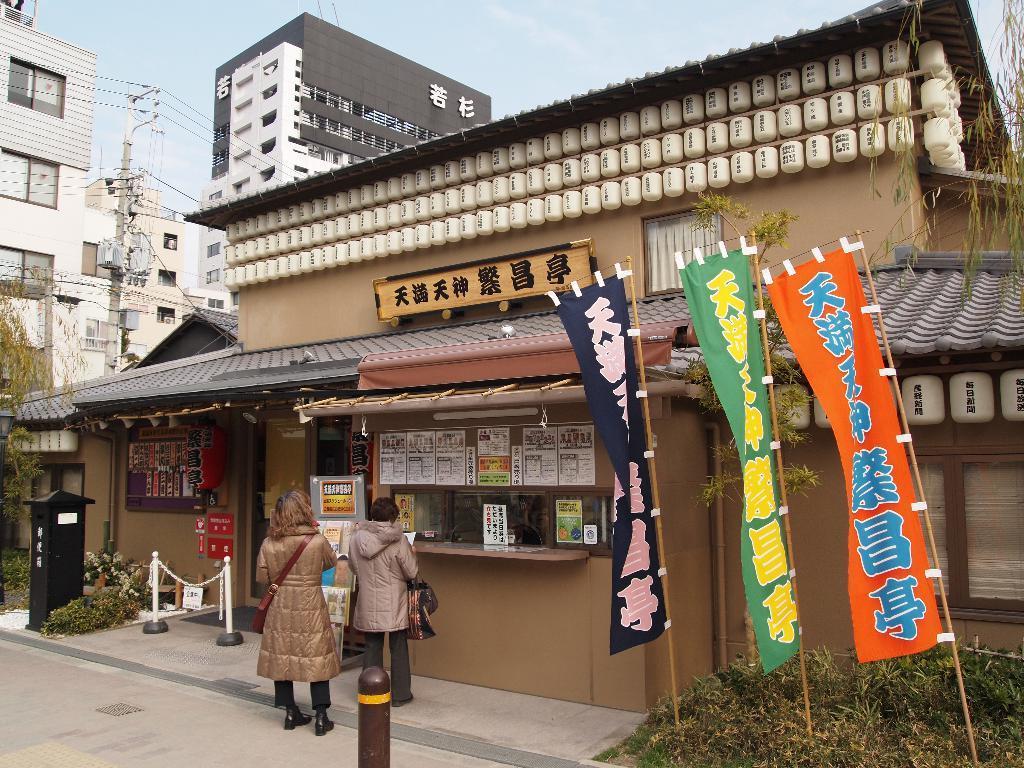Can you describe this image briefly? Here 2 persons are standing, they wore coats, this is the store building, At the top it is the sky. 